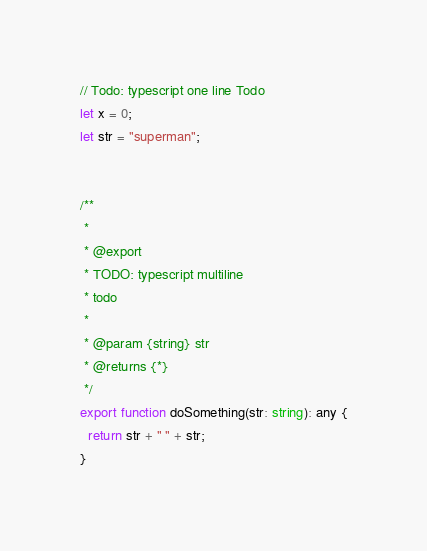<code> <loc_0><loc_0><loc_500><loc_500><_TypeScript_>// Todo: typescript one line Todo
let x = 0;
let str = "superman";


/**
 * 
 * @export
 * TODO: typescript multiline
 * todo
 * 
 * @param {string} str
 * @returns {*}
 */
export function doSomething(str: string): any {
  return str + " " + str;
}</code> 